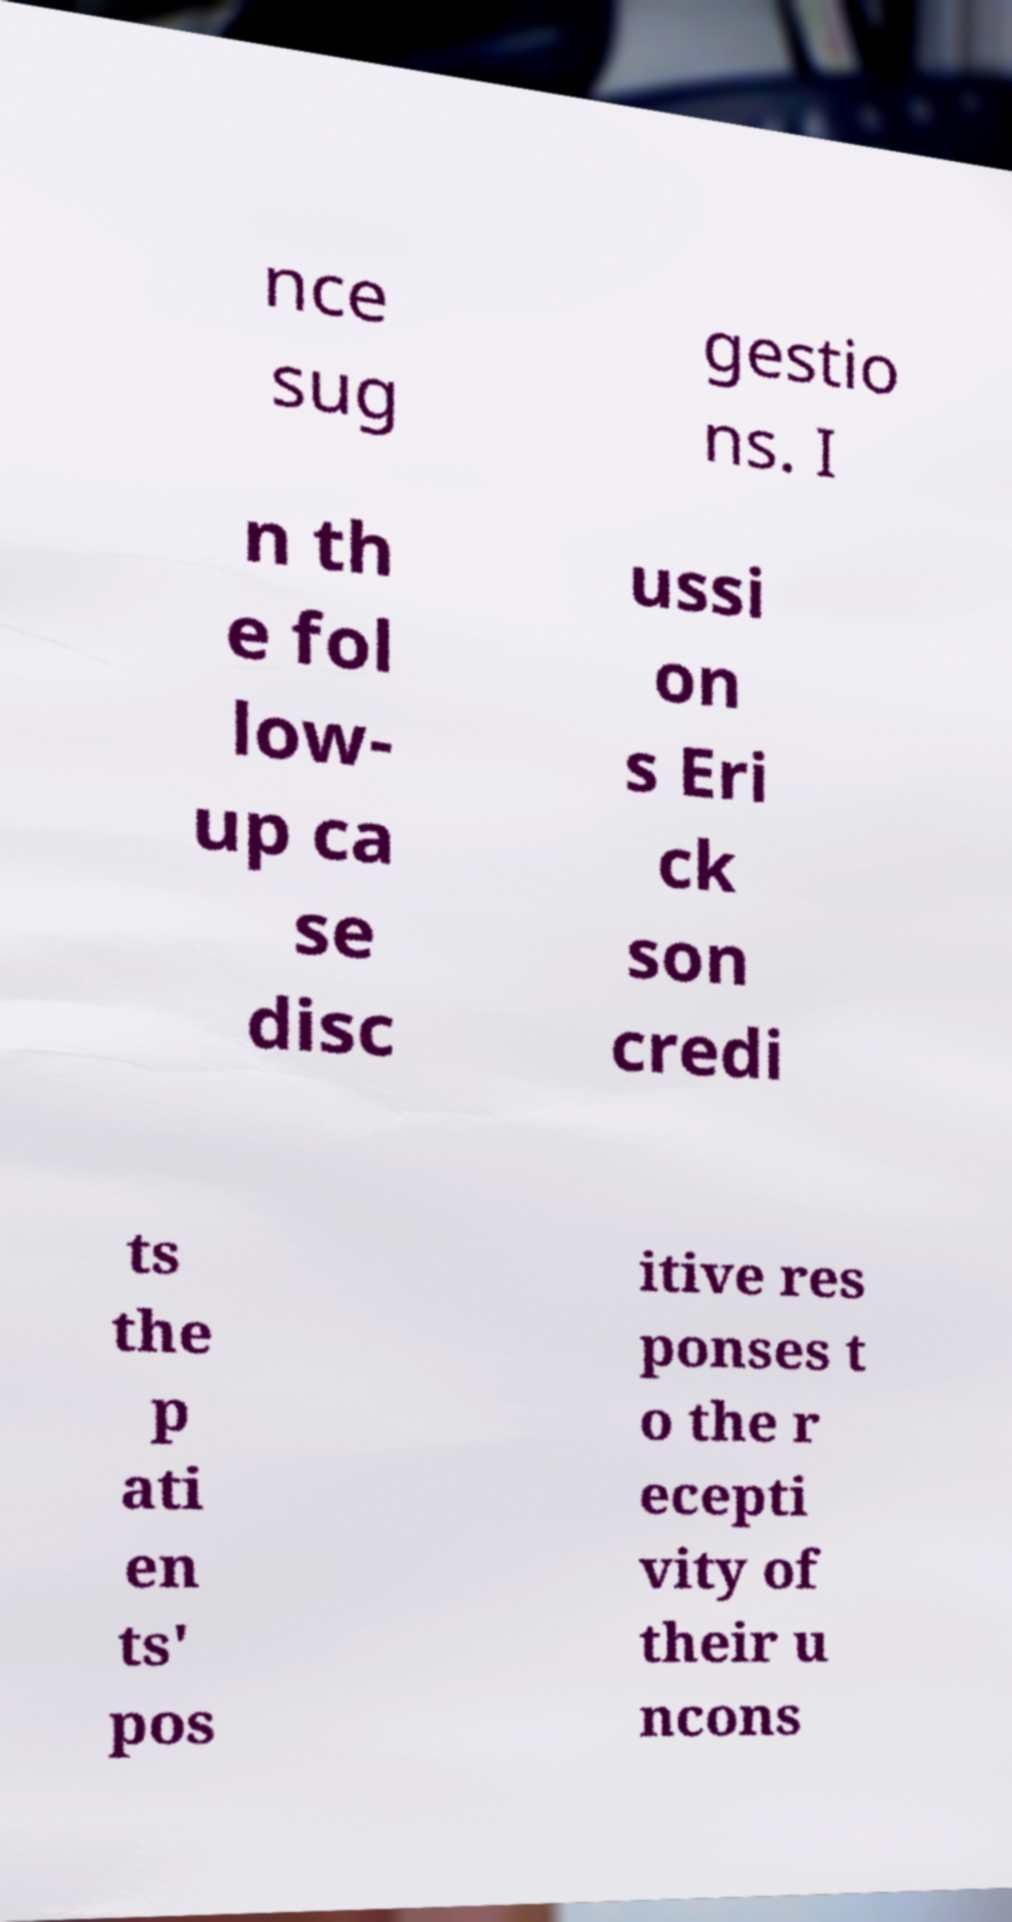Can you read and provide the text displayed in the image?This photo seems to have some interesting text. Can you extract and type it out for me? nce sug gestio ns. I n th e fol low- up ca se disc ussi on s Eri ck son credi ts the p ati en ts' pos itive res ponses t o the r ecepti vity of their u ncons 